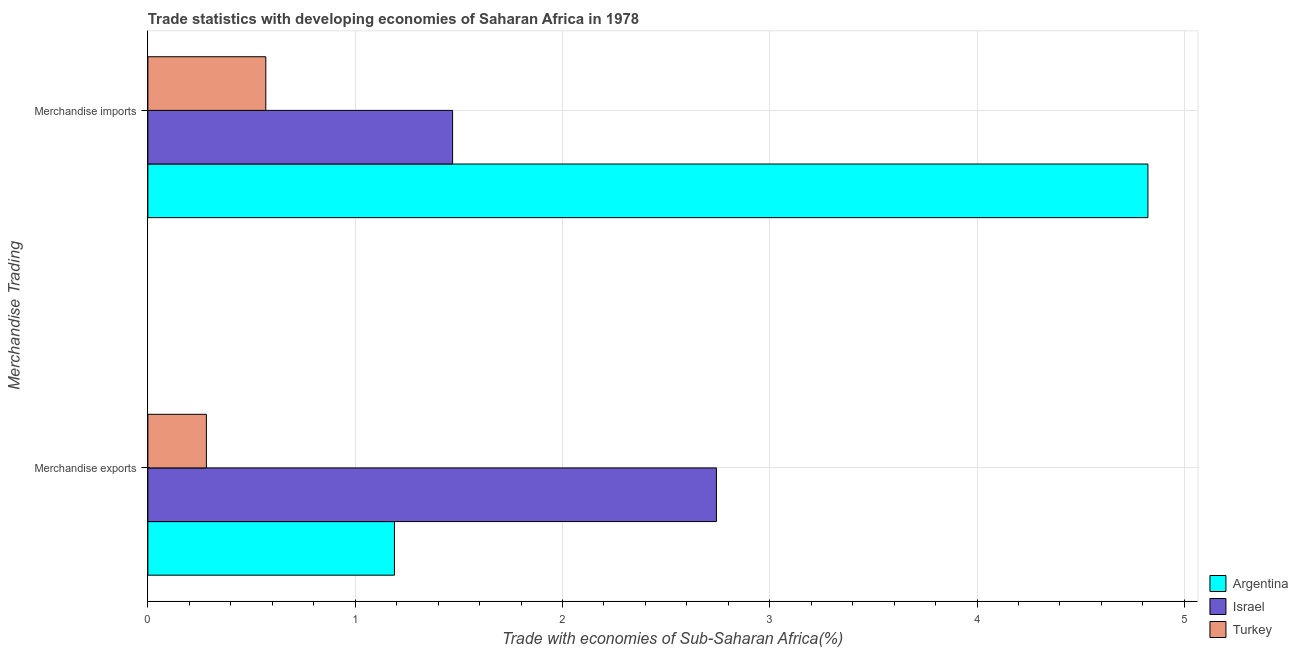How many groups of bars are there?
Provide a succinct answer. 2. Are the number of bars on each tick of the Y-axis equal?
Offer a terse response. Yes. What is the label of the 2nd group of bars from the top?
Make the answer very short. Merchandise exports. What is the merchandise exports in Argentina?
Offer a terse response. 1.19. Across all countries, what is the maximum merchandise imports?
Your answer should be very brief. 4.82. Across all countries, what is the minimum merchandise imports?
Offer a very short reply. 0.57. In which country was the merchandise exports maximum?
Offer a very short reply. Israel. What is the total merchandise exports in the graph?
Offer a terse response. 4.21. What is the difference between the merchandise imports in Argentina and that in Turkey?
Make the answer very short. 4.26. What is the difference between the merchandise exports in Argentina and the merchandise imports in Turkey?
Provide a short and direct response. 0.62. What is the average merchandise imports per country?
Provide a short and direct response. 2.29. What is the difference between the merchandise imports and merchandise exports in Turkey?
Offer a very short reply. 0.29. What is the ratio of the merchandise exports in Israel to that in Argentina?
Make the answer very short. 2.31. In how many countries, is the merchandise exports greater than the average merchandise exports taken over all countries?
Offer a very short reply. 1. What does the 2nd bar from the bottom in Merchandise imports represents?
Make the answer very short. Israel. How many bars are there?
Provide a short and direct response. 6. What is the difference between two consecutive major ticks on the X-axis?
Make the answer very short. 1. Are the values on the major ticks of X-axis written in scientific E-notation?
Keep it short and to the point. No. Does the graph contain any zero values?
Provide a succinct answer. No. Does the graph contain grids?
Your response must be concise. Yes. How many legend labels are there?
Offer a terse response. 3. How are the legend labels stacked?
Your response must be concise. Vertical. What is the title of the graph?
Keep it short and to the point. Trade statistics with developing economies of Saharan Africa in 1978. Does "Honduras" appear as one of the legend labels in the graph?
Provide a succinct answer. No. What is the label or title of the X-axis?
Ensure brevity in your answer.  Trade with economies of Sub-Saharan Africa(%). What is the label or title of the Y-axis?
Your answer should be very brief. Merchandise Trading. What is the Trade with economies of Sub-Saharan Africa(%) in Argentina in Merchandise exports?
Your answer should be very brief. 1.19. What is the Trade with economies of Sub-Saharan Africa(%) of Israel in Merchandise exports?
Your answer should be compact. 2.74. What is the Trade with economies of Sub-Saharan Africa(%) of Turkey in Merchandise exports?
Offer a terse response. 0.28. What is the Trade with economies of Sub-Saharan Africa(%) in Argentina in Merchandise imports?
Give a very brief answer. 4.82. What is the Trade with economies of Sub-Saharan Africa(%) of Israel in Merchandise imports?
Offer a very short reply. 1.47. What is the Trade with economies of Sub-Saharan Africa(%) in Turkey in Merchandise imports?
Offer a very short reply. 0.57. Across all Merchandise Trading, what is the maximum Trade with economies of Sub-Saharan Africa(%) in Argentina?
Offer a terse response. 4.82. Across all Merchandise Trading, what is the maximum Trade with economies of Sub-Saharan Africa(%) in Israel?
Give a very brief answer. 2.74. Across all Merchandise Trading, what is the maximum Trade with economies of Sub-Saharan Africa(%) of Turkey?
Give a very brief answer. 0.57. Across all Merchandise Trading, what is the minimum Trade with economies of Sub-Saharan Africa(%) in Argentina?
Give a very brief answer. 1.19. Across all Merchandise Trading, what is the minimum Trade with economies of Sub-Saharan Africa(%) of Israel?
Provide a succinct answer. 1.47. Across all Merchandise Trading, what is the minimum Trade with economies of Sub-Saharan Africa(%) in Turkey?
Your answer should be compact. 0.28. What is the total Trade with economies of Sub-Saharan Africa(%) in Argentina in the graph?
Give a very brief answer. 6.01. What is the total Trade with economies of Sub-Saharan Africa(%) in Israel in the graph?
Your response must be concise. 4.21. What is the total Trade with economies of Sub-Saharan Africa(%) of Turkey in the graph?
Ensure brevity in your answer.  0.85. What is the difference between the Trade with economies of Sub-Saharan Africa(%) in Argentina in Merchandise exports and that in Merchandise imports?
Your response must be concise. -3.63. What is the difference between the Trade with economies of Sub-Saharan Africa(%) of Israel in Merchandise exports and that in Merchandise imports?
Give a very brief answer. 1.27. What is the difference between the Trade with economies of Sub-Saharan Africa(%) of Turkey in Merchandise exports and that in Merchandise imports?
Provide a succinct answer. -0.29. What is the difference between the Trade with economies of Sub-Saharan Africa(%) of Argentina in Merchandise exports and the Trade with economies of Sub-Saharan Africa(%) of Israel in Merchandise imports?
Your answer should be compact. -0.28. What is the difference between the Trade with economies of Sub-Saharan Africa(%) in Argentina in Merchandise exports and the Trade with economies of Sub-Saharan Africa(%) in Turkey in Merchandise imports?
Ensure brevity in your answer.  0.62. What is the difference between the Trade with economies of Sub-Saharan Africa(%) of Israel in Merchandise exports and the Trade with economies of Sub-Saharan Africa(%) of Turkey in Merchandise imports?
Offer a very short reply. 2.17. What is the average Trade with economies of Sub-Saharan Africa(%) of Argentina per Merchandise Trading?
Keep it short and to the point. 3.01. What is the average Trade with economies of Sub-Saharan Africa(%) in Israel per Merchandise Trading?
Give a very brief answer. 2.11. What is the average Trade with economies of Sub-Saharan Africa(%) in Turkey per Merchandise Trading?
Your answer should be very brief. 0.43. What is the difference between the Trade with economies of Sub-Saharan Africa(%) of Argentina and Trade with economies of Sub-Saharan Africa(%) of Israel in Merchandise exports?
Give a very brief answer. -1.55. What is the difference between the Trade with economies of Sub-Saharan Africa(%) of Argentina and Trade with economies of Sub-Saharan Africa(%) of Turkey in Merchandise exports?
Keep it short and to the point. 0.91. What is the difference between the Trade with economies of Sub-Saharan Africa(%) of Israel and Trade with economies of Sub-Saharan Africa(%) of Turkey in Merchandise exports?
Keep it short and to the point. 2.46. What is the difference between the Trade with economies of Sub-Saharan Africa(%) in Argentina and Trade with economies of Sub-Saharan Africa(%) in Israel in Merchandise imports?
Give a very brief answer. 3.35. What is the difference between the Trade with economies of Sub-Saharan Africa(%) in Argentina and Trade with economies of Sub-Saharan Africa(%) in Turkey in Merchandise imports?
Your answer should be compact. 4.26. What is the difference between the Trade with economies of Sub-Saharan Africa(%) of Israel and Trade with economies of Sub-Saharan Africa(%) of Turkey in Merchandise imports?
Provide a short and direct response. 0.9. What is the ratio of the Trade with economies of Sub-Saharan Africa(%) of Argentina in Merchandise exports to that in Merchandise imports?
Your response must be concise. 0.25. What is the ratio of the Trade with economies of Sub-Saharan Africa(%) of Israel in Merchandise exports to that in Merchandise imports?
Give a very brief answer. 1.87. What is the ratio of the Trade with economies of Sub-Saharan Africa(%) in Turkey in Merchandise exports to that in Merchandise imports?
Make the answer very short. 0.5. What is the difference between the highest and the second highest Trade with economies of Sub-Saharan Africa(%) in Argentina?
Provide a short and direct response. 3.63. What is the difference between the highest and the second highest Trade with economies of Sub-Saharan Africa(%) of Israel?
Give a very brief answer. 1.27. What is the difference between the highest and the second highest Trade with economies of Sub-Saharan Africa(%) of Turkey?
Offer a terse response. 0.29. What is the difference between the highest and the lowest Trade with economies of Sub-Saharan Africa(%) of Argentina?
Give a very brief answer. 3.63. What is the difference between the highest and the lowest Trade with economies of Sub-Saharan Africa(%) of Israel?
Your response must be concise. 1.27. What is the difference between the highest and the lowest Trade with economies of Sub-Saharan Africa(%) of Turkey?
Keep it short and to the point. 0.29. 